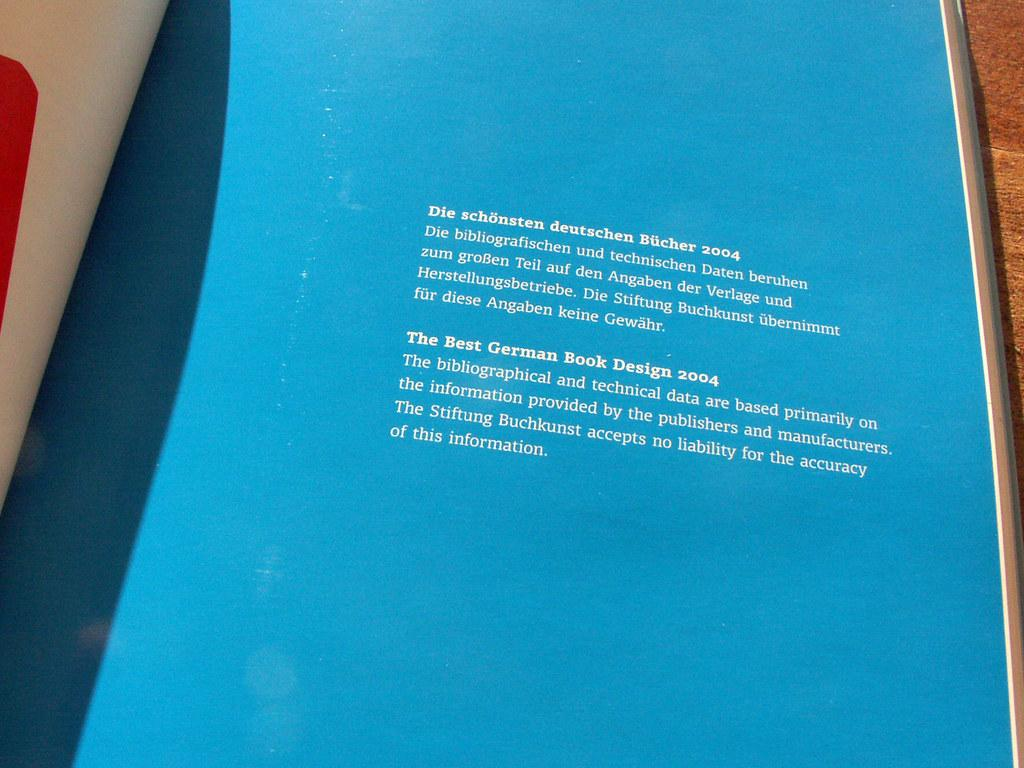<image>
Describe the image concisely. A magazine is opened to a page with a paragraph about German Book design in English and German. 